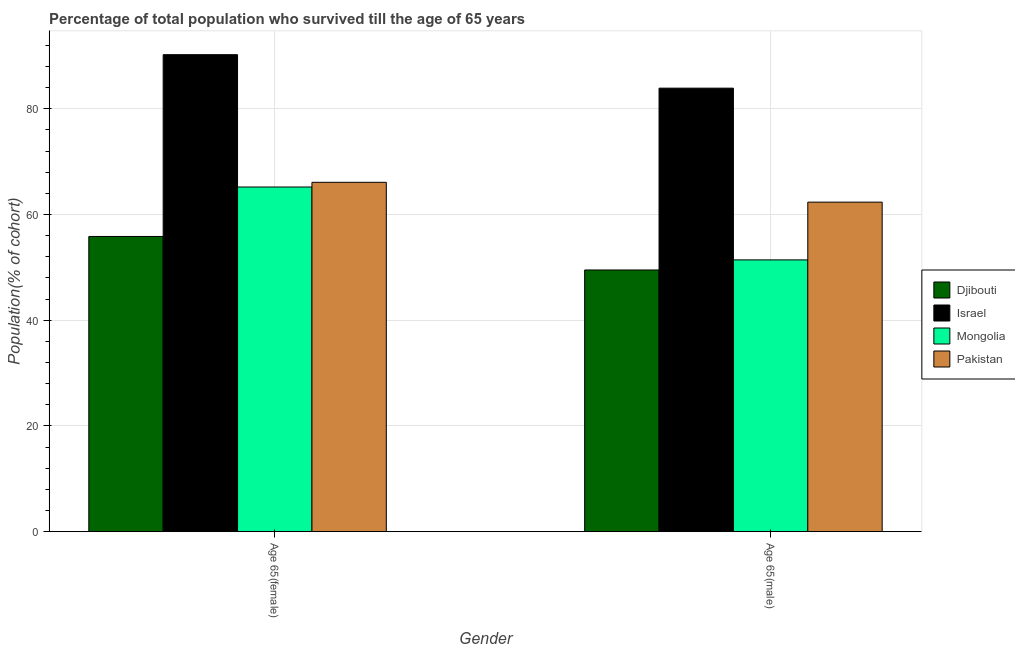How many groups of bars are there?
Provide a short and direct response. 2. Are the number of bars per tick equal to the number of legend labels?
Offer a very short reply. Yes. Are the number of bars on each tick of the X-axis equal?
Make the answer very short. Yes. How many bars are there on the 1st tick from the right?
Your answer should be very brief. 4. What is the label of the 1st group of bars from the left?
Offer a terse response. Age 65(female). What is the percentage of male population who survived till age of 65 in Mongolia?
Your response must be concise. 51.42. Across all countries, what is the maximum percentage of male population who survived till age of 65?
Provide a short and direct response. 83.9. Across all countries, what is the minimum percentage of female population who survived till age of 65?
Provide a succinct answer. 55.85. In which country was the percentage of male population who survived till age of 65 maximum?
Give a very brief answer. Israel. In which country was the percentage of male population who survived till age of 65 minimum?
Your response must be concise. Djibouti. What is the total percentage of male population who survived till age of 65 in the graph?
Provide a short and direct response. 247.16. What is the difference between the percentage of female population who survived till age of 65 in Israel and that in Pakistan?
Your answer should be very brief. 24.15. What is the difference between the percentage of female population who survived till age of 65 in Israel and the percentage of male population who survived till age of 65 in Mongolia?
Give a very brief answer. 38.82. What is the average percentage of male population who survived till age of 65 per country?
Provide a short and direct response. 61.79. What is the difference between the percentage of female population who survived till age of 65 and percentage of male population who survived till age of 65 in Mongolia?
Make the answer very short. 13.79. What is the ratio of the percentage of male population who survived till age of 65 in Israel to that in Pakistan?
Make the answer very short. 1.35. What does the 1st bar from the left in Age 65(female) represents?
Provide a succinct answer. Djibouti. How many bars are there?
Give a very brief answer. 8. What is the difference between two consecutive major ticks on the Y-axis?
Your answer should be compact. 20. Does the graph contain any zero values?
Ensure brevity in your answer.  No. Does the graph contain grids?
Ensure brevity in your answer.  Yes. Where does the legend appear in the graph?
Give a very brief answer. Center right. How many legend labels are there?
Provide a succinct answer. 4. What is the title of the graph?
Give a very brief answer. Percentage of total population who survived till the age of 65 years. What is the label or title of the Y-axis?
Your answer should be compact. Population(% of cohort). What is the Population(% of cohort) in Djibouti in Age 65(female)?
Give a very brief answer. 55.85. What is the Population(% of cohort) of Israel in Age 65(female)?
Your answer should be compact. 90.24. What is the Population(% of cohort) in Mongolia in Age 65(female)?
Your answer should be compact. 65.2. What is the Population(% of cohort) of Pakistan in Age 65(female)?
Provide a succinct answer. 66.09. What is the Population(% of cohort) in Djibouti in Age 65(male)?
Your response must be concise. 49.51. What is the Population(% of cohort) of Israel in Age 65(male)?
Provide a succinct answer. 83.9. What is the Population(% of cohort) in Mongolia in Age 65(male)?
Provide a short and direct response. 51.42. What is the Population(% of cohort) in Pakistan in Age 65(male)?
Ensure brevity in your answer.  62.34. Across all Gender, what is the maximum Population(% of cohort) in Djibouti?
Ensure brevity in your answer.  55.85. Across all Gender, what is the maximum Population(% of cohort) of Israel?
Provide a succinct answer. 90.24. Across all Gender, what is the maximum Population(% of cohort) in Mongolia?
Ensure brevity in your answer.  65.2. Across all Gender, what is the maximum Population(% of cohort) of Pakistan?
Your answer should be compact. 66.09. Across all Gender, what is the minimum Population(% of cohort) in Djibouti?
Offer a terse response. 49.51. Across all Gender, what is the minimum Population(% of cohort) of Israel?
Provide a short and direct response. 83.9. Across all Gender, what is the minimum Population(% of cohort) of Mongolia?
Offer a very short reply. 51.42. Across all Gender, what is the minimum Population(% of cohort) of Pakistan?
Offer a terse response. 62.34. What is the total Population(% of cohort) in Djibouti in the graph?
Provide a short and direct response. 105.36. What is the total Population(% of cohort) in Israel in the graph?
Make the answer very short. 174.14. What is the total Population(% of cohort) in Mongolia in the graph?
Provide a succinct answer. 116.62. What is the total Population(% of cohort) of Pakistan in the graph?
Ensure brevity in your answer.  128.43. What is the difference between the Population(% of cohort) of Djibouti in Age 65(female) and that in Age 65(male)?
Give a very brief answer. 6.34. What is the difference between the Population(% of cohort) in Israel in Age 65(female) and that in Age 65(male)?
Keep it short and to the point. 6.33. What is the difference between the Population(% of cohort) in Mongolia in Age 65(female) and that in Age 65(male)?
Your response must be concise. 13.79. What is the difference between the Population(% of cohort) in Pakistan in Age 65(female) and that in Age 65(male)?
Your answer should be compact. 3.75. What is the difference between the Population(% of cohort) of Djibouti in Age 65(female) and the Population(% of cohort) of Israel in Age 65(male)?
Give a very brief answer. -28.05. What is the difference between the Population(% of cohort) of Djibouti in Age 65(female) and the Population(% of cohort) of Mongolia in Age 65(male)?
Give a very brief answer. 4.43. What is the difference between the Population(% of cohort) in Djibouti in Age 65(female) and the Population(% of cohort) in Pakistan in Age 65(male)?
Give a very brief answer. -6.49. What is the difference between the Population(% of cohort) in Israel in Age 65(female) and the Population(% of cohort) in Mongolia in Age 65(male)?
Your answer should be compact. 38.82. What is the difference between the Population(% of cohort) of Israel in Age 65(female) and the Population(% of cohort) of Pakistan in Age 65(male)?
Provide a succinct answer. 27.9. What is the difference between the Population(% of cohort) of Mongolia in Age 65(female) and the Population(% of cohort) of Pakistan in Age 65(male)?
Provide a short and direct response. 2.87. What is the average Population(% of cohort) in Djibouti per Gender?
Keep it short and to the point. 52.68. What is the average Population(% of cohort) of Israel per Gender?
Offer a terse response. 87.07. What is the average Population(% of cohort) of Mongolia per Gender?
Your answer should be compact. 58.31. What is the average Population(% of cohort) in Pakistan per Gender?
Keep it short and to the point. 64.21. What is the difference between the Population(% of cohort) in Djibouti and Population(% of cohort) in Israel in Age 65(female)?
Make the answer very short. -34.39. What is the difference between the Population(% of cohort) in Djibouti and Population(% of cohort) in Mongolia in Age 65(female)?
Make the answer very short. -9.36. What is the difference between the Population(% of cohort) of Djibouti and Population(% of cohort) of Pakistan in Age 65(female)?
Your answer should be very brief. -10.24. What is the difference between the Population(% of cohort) in Israel and Population(% of cohort) in Mongolia in Age 65(female)?
Your response must be concise. 25.03. What is the difference between the Population(% of cohort) in Israel and Population(% of cohort) in Pakistan in Age 65(female)?
Provide a succinct answer. 24.15. What is the difference between the Population(% of cohort) in Mongolia and Population(% of cohort) in Pakistan in Age 65(female)?
Offer a very short reply. -0.89. What is the difference between the Population(% of cohort) of Djibouti and Population(% of cohort) of Israel in Age 65(male)?
Offer a very short reply. -34.39. What is the difference between the Population(% of cohort) of Djibouti and Population(% of cohort) of Mongolia in Age 65(male)?
Ensure brevity in your answer.  -1.91. What is the difference between the Population(% of cohort) of Djibouti and Population(% of cohort) of Pakistan in Age 65(male)?
Offer a very short reply. -12.83. What is the difference between the Population(% of cohort) of Israel and Population(% of cohort) of Mongolia in Age 65(male)?
Keep it short and to the point. 32.48. What is the difference between the Population(% of cohort) in Israel and Population(% of cohort) in Pakistan in Age 65(male)?
Your response must be concise. 21.56. What is the difference between the Population(% of cohort) of Mongolia and Population(% of cohort) of Pakistan in Age 65(male)?
Ensure brevity in your answer.  -10.92. What is the ratio of the Population(% of cohort) in Djibouti in Age 65(female) to that in Age 65(male)?
Offer a very short reply. 1.13. What is the ratio of the Population(% of cohort) in Israel in Age 65(female) to that in Age 65(male)?
Ensure brevity in your answer.  1.08. What is the ratio of the Population(% of cohort) of Mongolia in Age 65(female) to that in Age 65(male)?
Your answer should be compact. 1.27. What is the ratio of the Population(% of cohort) of Pakistan in Age 65(female) to that in Age 65(male)?
Your answer should be very brief. 1.06. What is the difference between the highest and the second highest Population(% of cohort) of Djibouti?
Provide a succinct answer. 6.34. What is the difference between the highest and the second highest Population(% of cohort) in Israel?
Offer a very short reply. 6.33. What is the difference between the highest and the second highest Population(% of cohort) in Mongolia?
Ensure brevity in your answer.  13.79. What is the difference between the highest and the second highest Population(% of cohort) of Pakistan?
Keep it short and to the point. 3.75. What is the difference between the highest and the lowest Population(% of cohort) of Djibouti?
Your answer should be very brief. 6.34. What is the difference between the highest and the lowest Population(% of cohort) of Israel?
Ensure brevity in your answer.  6.33. What is the difference between the highest and the lowest Population(% of cohort) in Mongolia?
Your answer should be compact. 13.79. What is the difference between the highest and the lowest Population(% of cohort) of Pakistan?
Give a very brief answer. 3.75. 